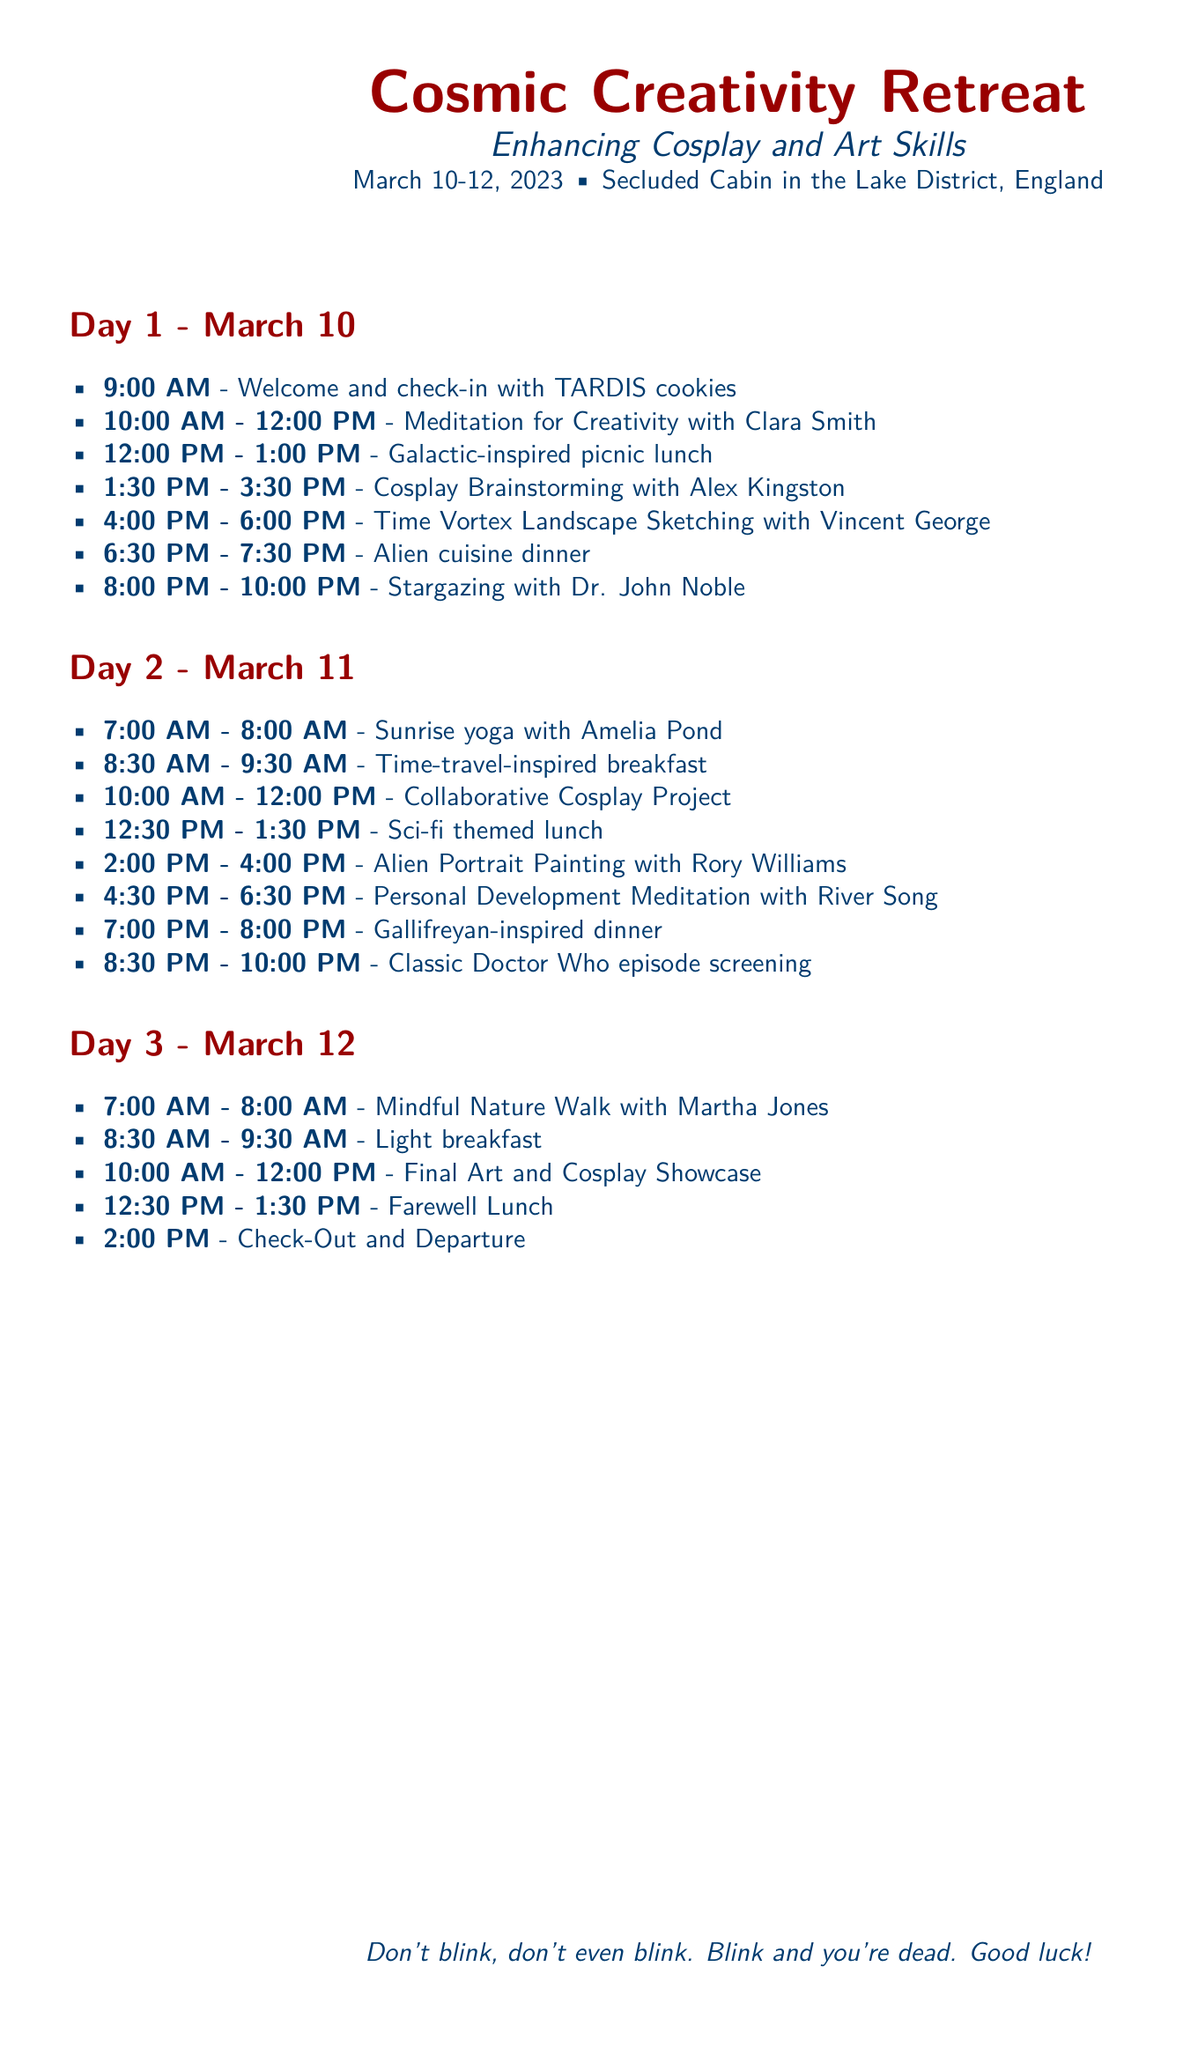What is the location of the retreat? The location of the retreat is mentioned as the Lake District, England.
Answer: Lake District, England What is the start date of the retreat? The start date of the retreat is specified in the document as March 10, 2023.
Answer: March 10, 2023 Who is leading the meditation session on Day 1? The document specifies that Clara Smith is leading the meditation session for creativity.
Answer: Clara Smith What time does the final art and cosplay showcase start on Day 3? The itinerary indicates that the final art and cosplay showcase starts at 10:00 AM on Day 3.
Answer: 10:00 AM How many meals are included on Day 2? By reviewing the itinerary, it can be counted that there are four meals mentioned for Day 2.
Answer: Four What activity occurs immediately after the “Time Vortex Landscape Sketching”? The document indicates that the next activity after that session is an alien cuisine dinner.
Answer: Alien cuisine dinner What is the theme of the breakfast on Day 2? The theme of the breakfast is stated as time-travel-inspired breakfast.
Answer: Time-travel-inspired breakfast Who is hosting the night-time stargazing session? The document mentions that Dr. John Noble is hosting the stargazing session on Day 1.
Answer: Dr. John Noble What is the farewell activity scheduled on the last day? The farewell activity listed is a farewell lunch before check-out.
Answer: Farewell Lunch 